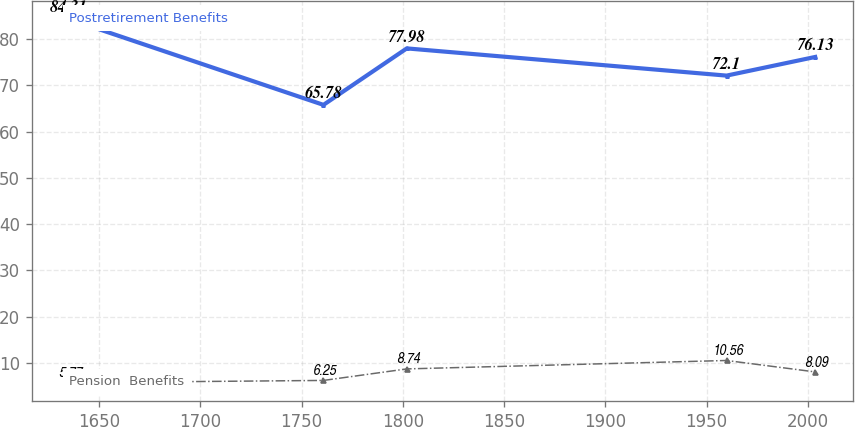Convert chart. <chart><loc_0><loc_0><loc_500><loc_500><line_chart><ecel><fcel>Postretirement Benefits<fcel>Pension  Benefits<nl><fcel>1635.14<fcel>84.31<fcel>5.77<nl><fcel>1760.83<fcel>65.78<fcel>6.25<nl><fcel>1801.98<fcel>77.98<fcel>8.74<nl><fcel>1959.89<fcel>72.1<fcel>10.56<nl><fcel>2003.66<fcel>76.13<fcel>8.09<nl></chart> 